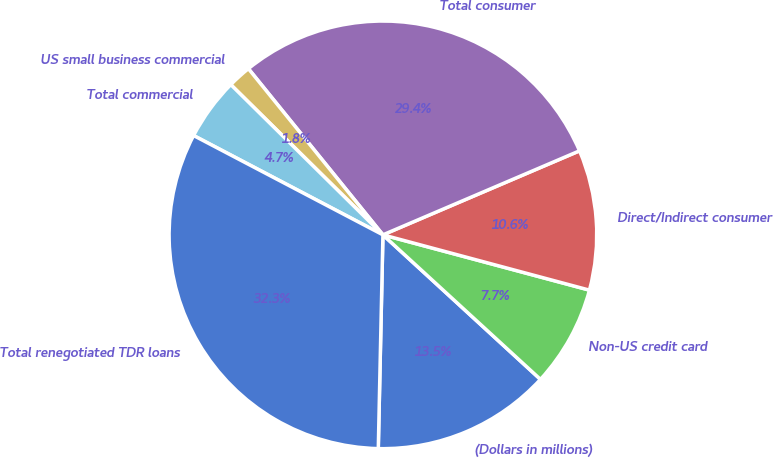Convert chart to OTSL. <chart><loc_0><loc_0><loc_500><loc_500><pie_chart><fcel>(Dollars in millions)<fcel>Non-US credit card<fcel>Direct/Indirect consumer<fcel>Total consumer<fcel>US small business commercial<fcel>Total commercial<fcel>Total renegotiated TDR loans<nl><fcel>13.53%<fcel>7.65%<fcel>10.59%<fcel>29.4%<fcel>1.77%<fcel>4.71%<fcel>32.34%<nl></chart> 